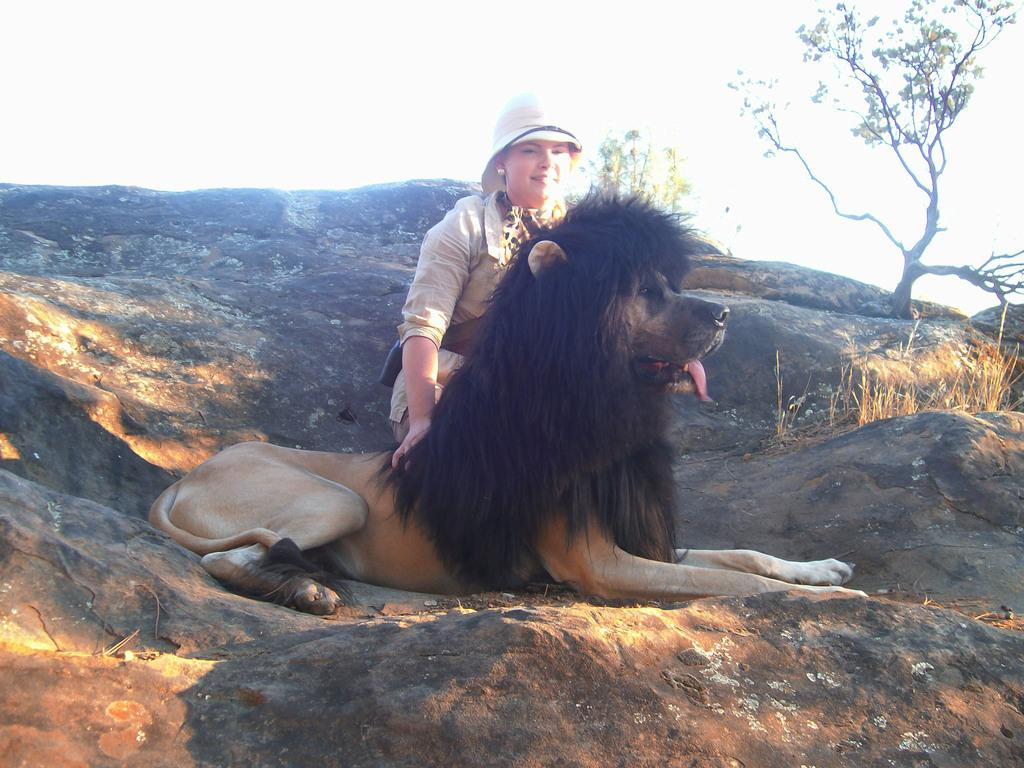Who or what can be seen in the image? There is a person and an animal in the image. Where are the person and the animal located? Both the person and the animal are on a rock. What can be seen in the background of the image? There are trees and the sky visible in the background of the image. How many cherries are hanging from the icicle in the image? There is no icicle or cherries present in the image. 